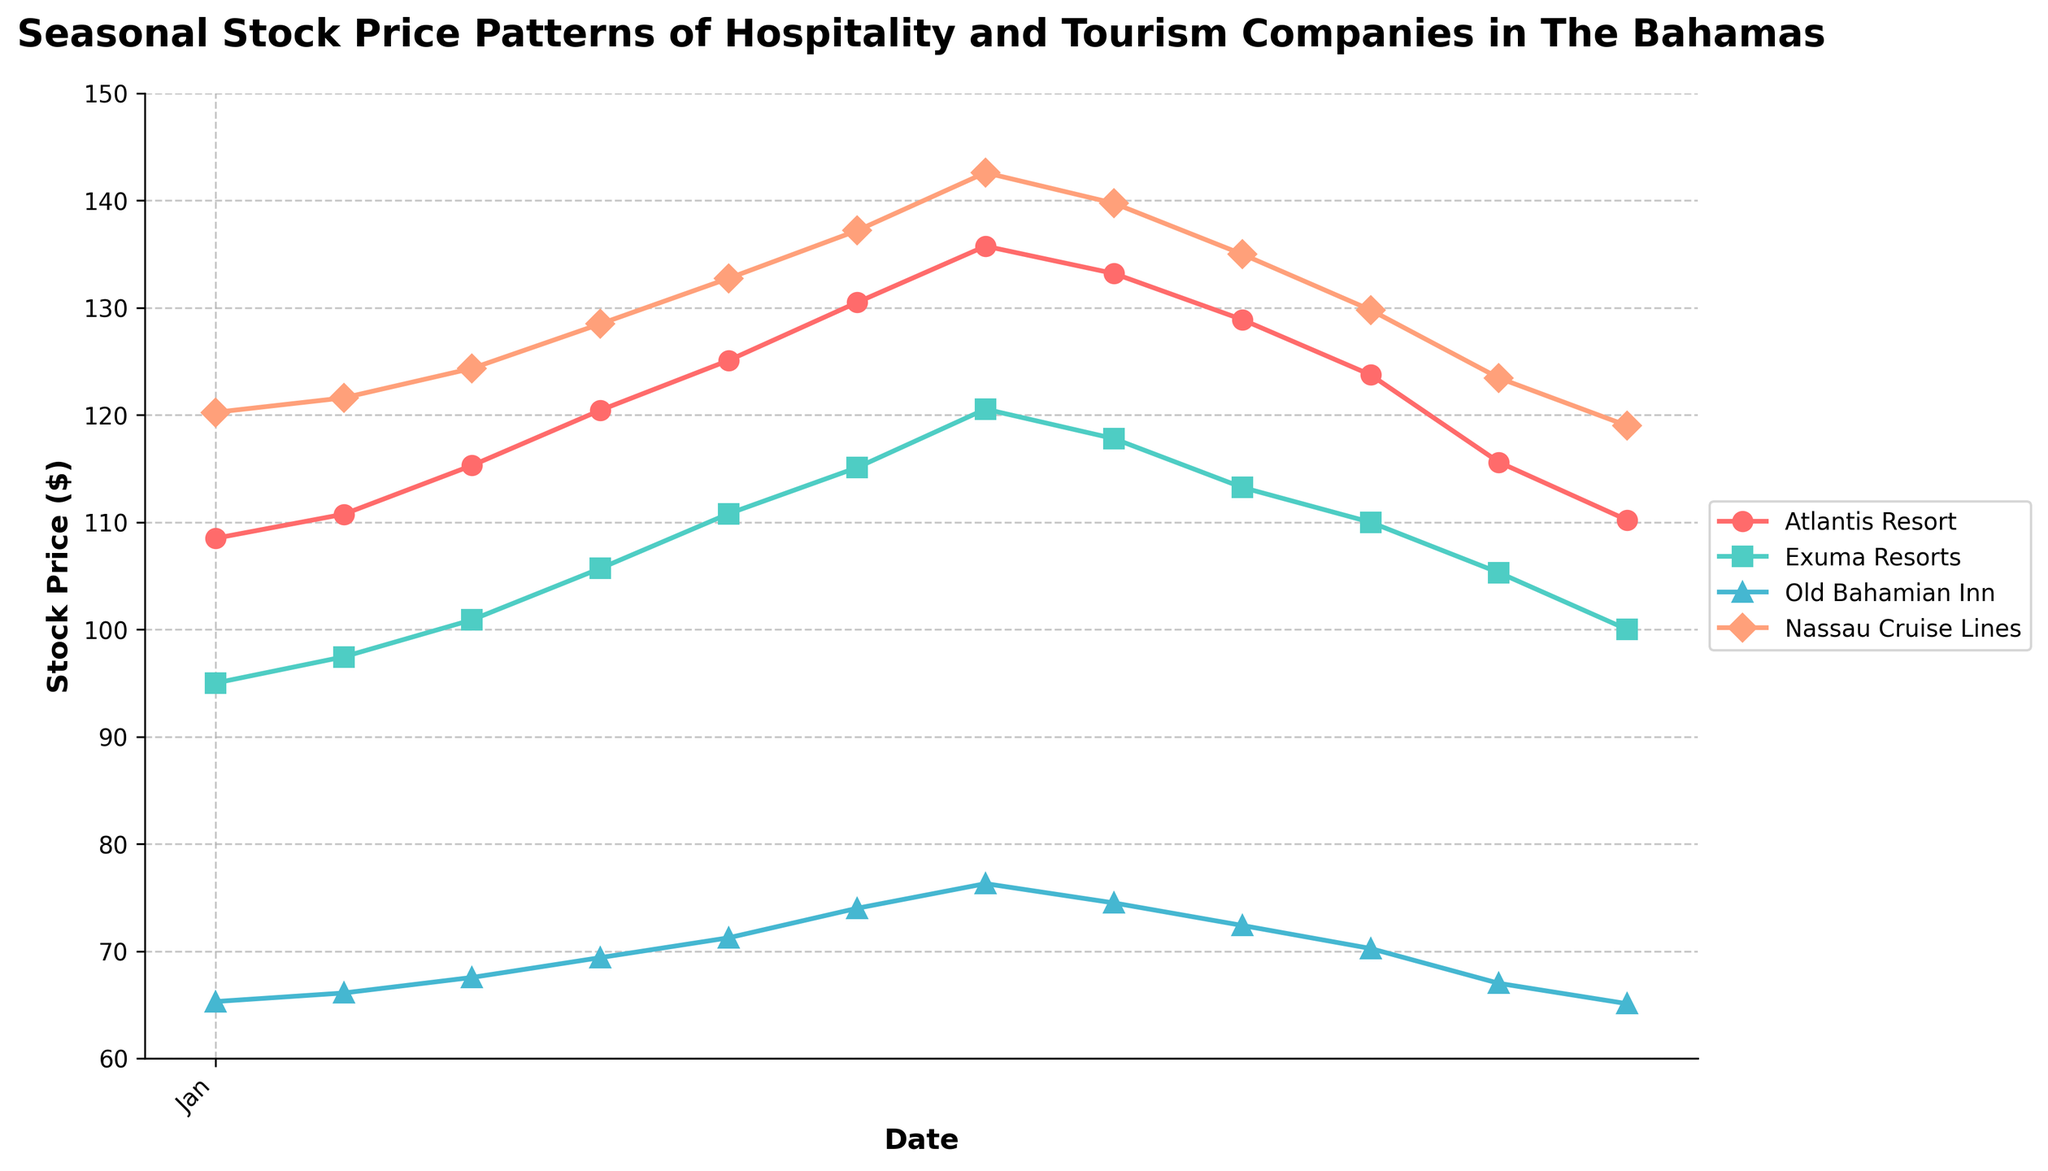What are the colors used to represent the different companies on the plot? The colors used to represent the different companies are: '#FF6B6B' for Atlantis Resort, '#4ECDC4' for Exuma Resorts, '#45B7D1' for Old Bahamian Inn, and '#FFA07A' for Nassau Cruise Lines.
Answer: Red, Teal, Blue, Salmon What is the overall trend of Atlantis Resort's stock price throughout the year? The stock price of Atlantis Resort generally increases from January to July, reaching a peak in July, then decreases towards the end of the year.
Answer: Increases then decreases Which company's stock price is highest in July? In July, the highest stock price among the given companies is for Nassau Cruise Lines, which is reflected by the data and the plot's visual information.
Answer: Nassau Cruise Lines What is the title of the plot? The title of the plot is prominently displayed at the top and reads "Seasonal Stock Price Patterns of Hospitality and Tourism Companies in The Bahamas".
Answer: Seasonal Stock Price Patterns of Hospitality and Tourism Companies in The Bahamas How does the stock price of Exuma Resorts change between June and August? From June to August, the stock price of Exuma Resorts increases from June to July, then decreases in August as can be observed from the plot.
Answer: Increases then decreases What is the range of stock prices for Old Bahamian Inn throughout the year? The minimum stock price for Old Bahamian Inn is approximately $65.10 in December and the maximum is about $76.30 in July, showing a range.
Answer: $65.10 to $76.30 Which company has the most noticeable seasonal decrease in stock price towards the end of the year? By visually comparing the lines, Atlantis Resort has the most noticeable seasonal decrease in stock price towards the end of the year, descending sharply after July.
Answer: Atlantis Resort What is the stock price difference for Nassau Cruise Lines between January and December? In January, Nassau Cruise Lines' stock price is 120.25, and in December, it is 119.00. The difference can be calculated as 120.25 - 119.00.
Answer: 1.25 During which month did Atlantis Resort's stock price experience its maximum value? The maximum value for Atlantis Resort's stock price throughout the year was reached in July, according to the plot.
Answer: July What is the average stock price of Exuma Resorts for the months June to September? To find the average for Exuma Resorts from June to September, you sum the prices in these months (115.10, 120.55, 117.80, 113.25) and divide by the number of months, which is 4: (115.10 + 120.55 + 117.80 + 113.25) / 4 = 116.675.
Answer: 116.675 